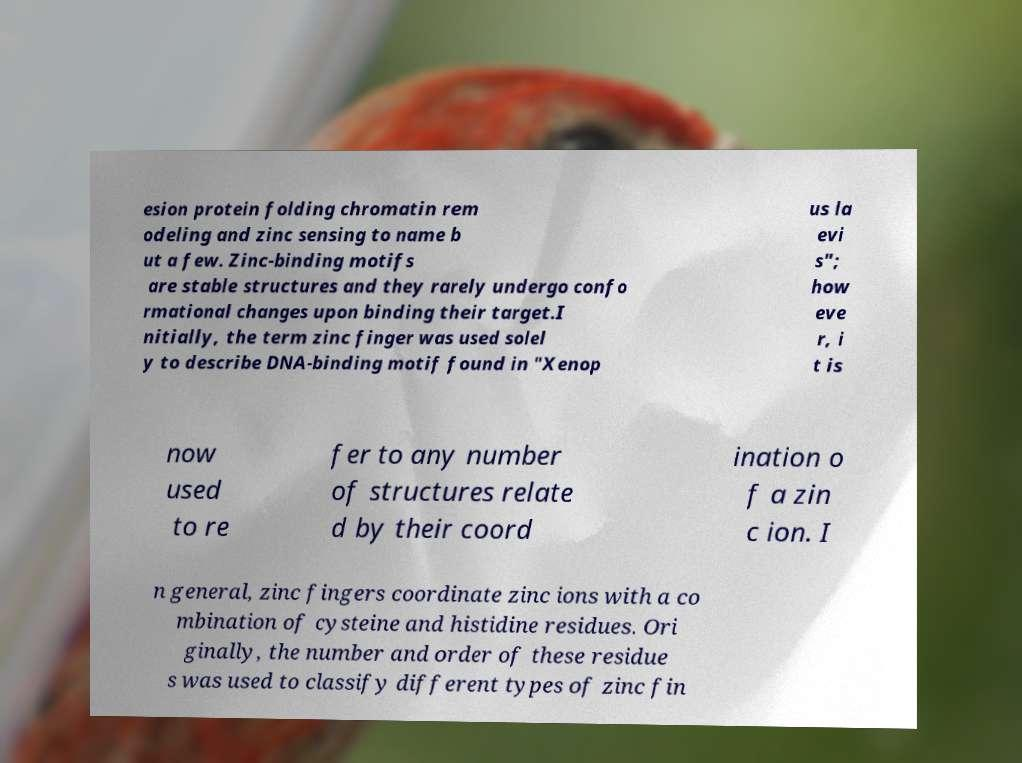What messages or text are displayed in this image? I need them in a readable, typed format. esion protein folding chromatin rem odeling and zinc sensing to name b ut a few. Zinc-binding motifs are stable structures and they rarely undergo confo rmational changes upon binding their target.I nitially, the term zinc finger was used solel y to describe DNA-binding motif found in "Xenop us la evi s"; how eve r, i t is now used to re fer to any number of structures relate d by their coord ination o f a zin c ion. I n general, zinc fingers coordinate zinc ions with a co mbination of cysteine and histidine residues. Ori ginally, the number and order of these residue s was used to classify different types of zinc fin 